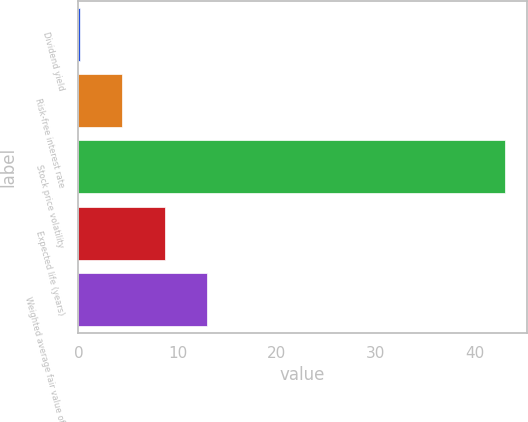<chart> <loc_0><loc_0><loc_500><loc_500><bar_chart><fcel>Dividend yield<fcel>Risk-free interest rate<fcel>Stock price volatility<fcel>Expected life (years)<fcel>Weighted average fair value of<nl><fcel>0.13<fcel>4.43<fcel>43.1<fcel>8.73<fcel>13.03<nl></chart> 